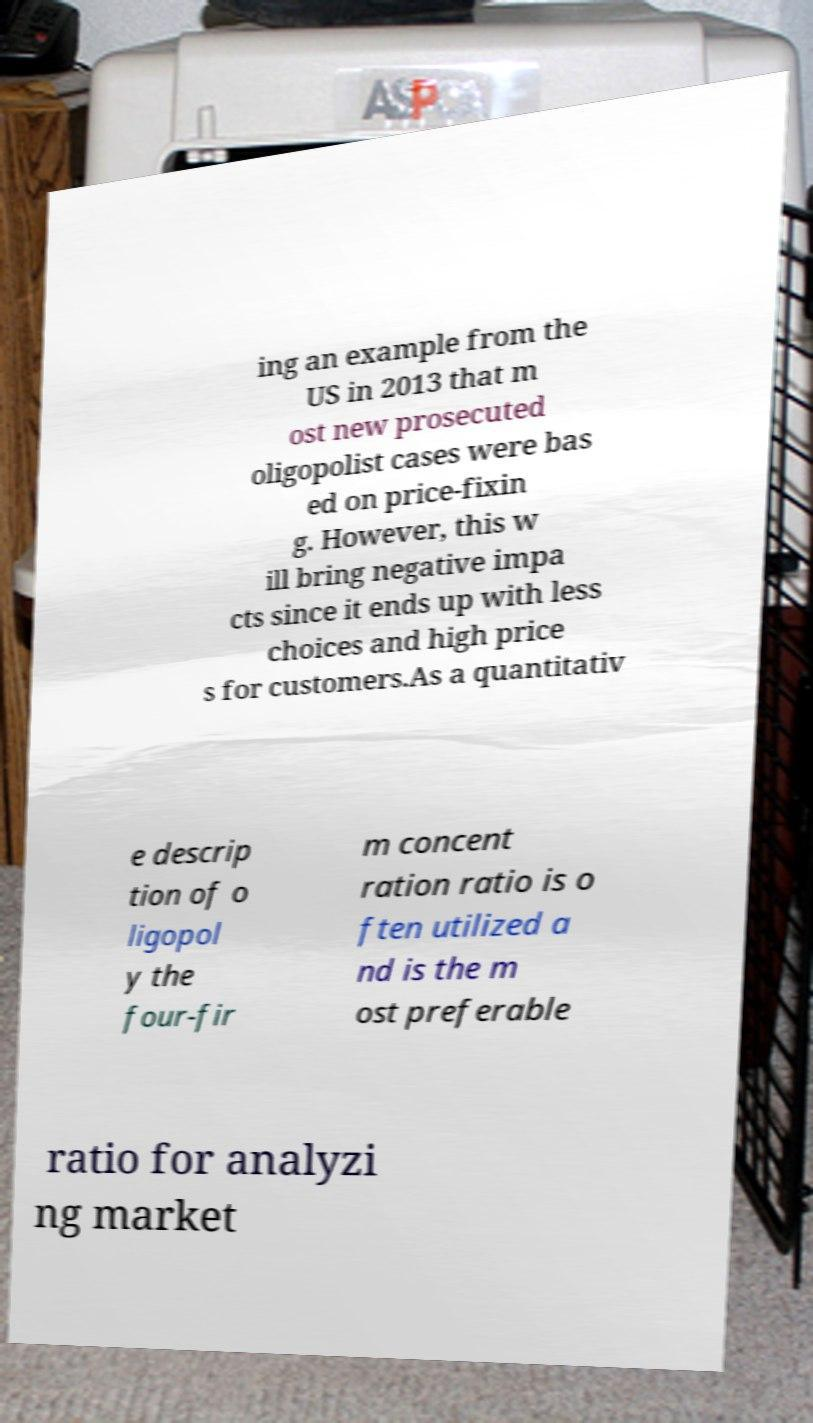Please read and relay the text visible in this image. What does it say? ing an example from the US in 2013 that m ost new prosecuted oligopolist cases were bas ed on price-fixin g. However, this w ill bring negative impa cts since it ends up with less choices and high price s for customers.As a quantitativ e descrip tion of o ligopol y the four-fir m concent ration ratio is o ften utilized a nd is the m ost preferable ratio for analyzi ng market 